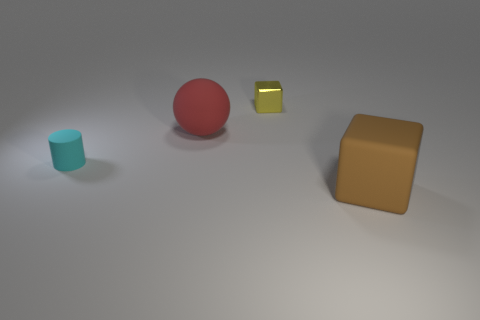There is a thing that is both in front of the red thing and behind the large brown rubber block; what is its material?
Your response must be concise. Rubber. What is the color of the thing that is both on the right side of the cyan matte thing and left of the tiny yellow metal block?
Give a very brief answer. Red. There is a small thing on the right side of the tiny thing that is to the left of the object that is behind the red object; what is its shape?
Keep it short and to the point. Cube. There is another shiny object that is the same shape as the brown thing; what color is it?
Offer a terse response. Yellow. The small object on the left side of the thing that is behind the big red matte sphere is what color?
Ensure brevity in your answer.  Cyan. There is a matte object that is the same shape as the yellow metallic thing; what size is it?
Give a very brief answer. Large. What number of big brown objects have the same material as the yellow thing?
Ensure brevity in your answer.  0. There is a big object that is behind the big matte block; how many red rubber objects are right of it?
Keep it short and to the point. 0. Are there any tiny yellow metal cubes on the left side of the large brown matte block?
Offer a terse response. Yes. There is a small object that is behind the big rubber ball; does it have the same shape as the red rubber object?
Make the answer very short. No. 